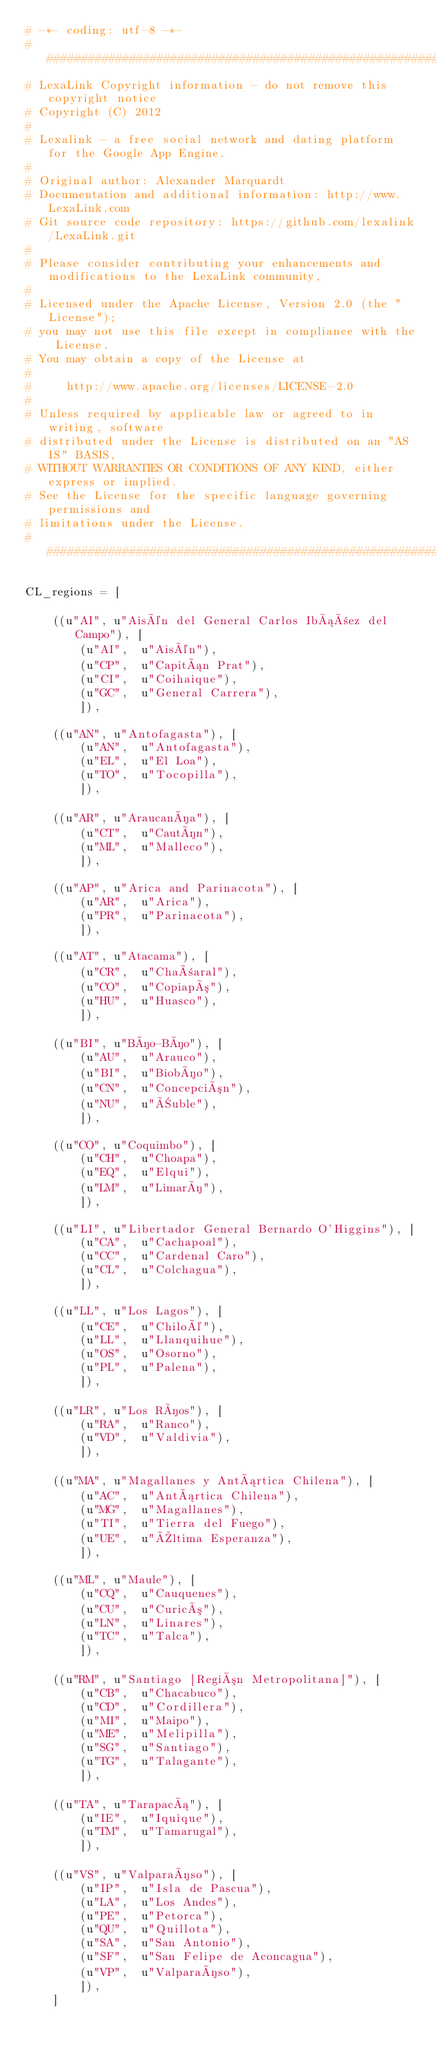<code> <loc_0><loc_0><loc_500><loc_500><_Python_># -*- coding: utf-8 -*- 
################################################################################
# LexaLink Copyright information - do not remove this copyright notice
# Copyright (C) 2012 
#
# Lexalink - a free social network and dating platform for the Google App Engine. 
#
# Original author: Alexander Marquardt
# Documentation and additional information: http://www.LexaLink.com
# Git source code repository: https://github.com/lexalink/LexaLink.git 
#
# Please consider contributing your enhancements and modifications to the LexaLink community, 
#
# Licensed under the Apache License, Version 2.0 (the "License");
# you may not use this file except in compliance with the License.
# You may obtain a copy of the License at
#
#     http://www.apache.org/licenses/LICENSE-2.0
#
# Unless required by applicable law or agreed to in writing, software
# distributed under the License is distributed on an "AS IS" BASIS,
# WITHOUT WARRANTIES OR CONDITIONS OF ANY KIND, either express or implied.
# See the License for the specific language governing permissions and
# limitations under the License.
################################################################################

CL_regions = [  
    
    ((u"AI", u"Aisén del General Carlos Ibáñez del Campo"), [
        (u"AI",  u"Aisén"),
        (u"CP",  u"Capitán Prat"),
        (u"CI",  u"Coihaique"),
        (u"GC",  u"General Carrera"),
        ]),

    ((u"AN", u"Antofagasta"), [
        (u"AN",  u"Antofagasta"),
        (u"EL",  u"El Loa"),
        (u"TO",  u"Tocopilla"),
        ]),

    ((u"AR", u"Araucanía"), [
        (u"CT",  u"Cautín"),
        (u"ML",  u"Malleco"),
        ]),

    ((u"AP", u"Arica and Parinacota"), [
        (u"AR",  u"Arica"),
        (u"PR",  u"Parinacota"),
        ]),

    ((u"AT", u"Atacama"), [
        (u"CR",  u"Chañaral"),
        (u"CO",  u"Copiapó"),
        (u"HU",  u"Huasco"),
        ]),

    ((u"BI", u"Bío-Bío"), [
        (u"AU",  u"Arauco"),
        (u"BI",  u"Biobío"),
        (u"CN",  u"Concepción"),
        (u"NU",  u"Ñuble"),
        ]),

    ((u"CO", u"Coquimbo"), [
        (u"CH",  u"Choapa"),
        (u"EQ",  u"Elqui"),
        (u"LM",  u"Limarí"),
        ]),

    ((u"LI", u"Libertador General Bernardo O'Higgins"), [
        (u"CA",  u"Cachapoal"),
        (u"CC",  u"Cardenal Caro"),
        (u"CL",  u"Colchagua"),
        ]),

    ((u"LL", u"Los Lagos"), [
        (u"CE",  u"Chiloé"),
        (u"LL",  u"Llanquihue"),
        (u"OS",  u"Osorno"),
        (u"PL",  u"Palena"),
        ]),

    ((u"LR", u"Los Ríos"), [
        (u"RA",  u"Ranco"),
        (u"VD",  u"Valdivia"),
        ]),

    ((u"MA", u"Magallanes y Antártica Chilena"), [
        (u"AC",  u"Antártica Chilena"),
        (u"MG",  u"Magallanes"),
        (u"TI",  u"Tierra del Fuego"),
        (u"UE",  u"Última Esperanza"),
        ]),

    ((u"ML", u"Maule"), [
        (u"CQ",  u"Cauquenes"),
        (u"CU",  u"Curicó"),
        (u"LN",  u"Linares"),
        (u"TC",  u"Talca"),
        ]),

    ((u"RM", u"Santiago [Región Metropolitana]"), [
        (u"CB",  u"Chacabuco"),
        (u"CD",  u"Cordillera"),
        (u"MI",  u"Maipo"),
        (u"ME",  u"Melipilla"),
        (u"SG",  u"Santiago"),
        (u"TG",  u"Talagante"),
        ]),

    ((u"TA", u"Tarapacá"), [
        (u"IE",  u"Iquique"),
        (u"TM",  u"Tamarugal"),
        ]),

    ((u"VS", u"Valparaíso"), [
        (u"IP",  u"Isla de Pascua"),
        (u"LA",  u"Los Andes"),
        (u"PE",  u"Petorca"),
        (u"QU",  u"Quillota"),
        (u"SA",  u"San Antonio"),
        (u"SF",  u"San Felipe de Aconcagua"),
        (u"VP",  u"Valparaíso"),
        ]),
    ]</code> 